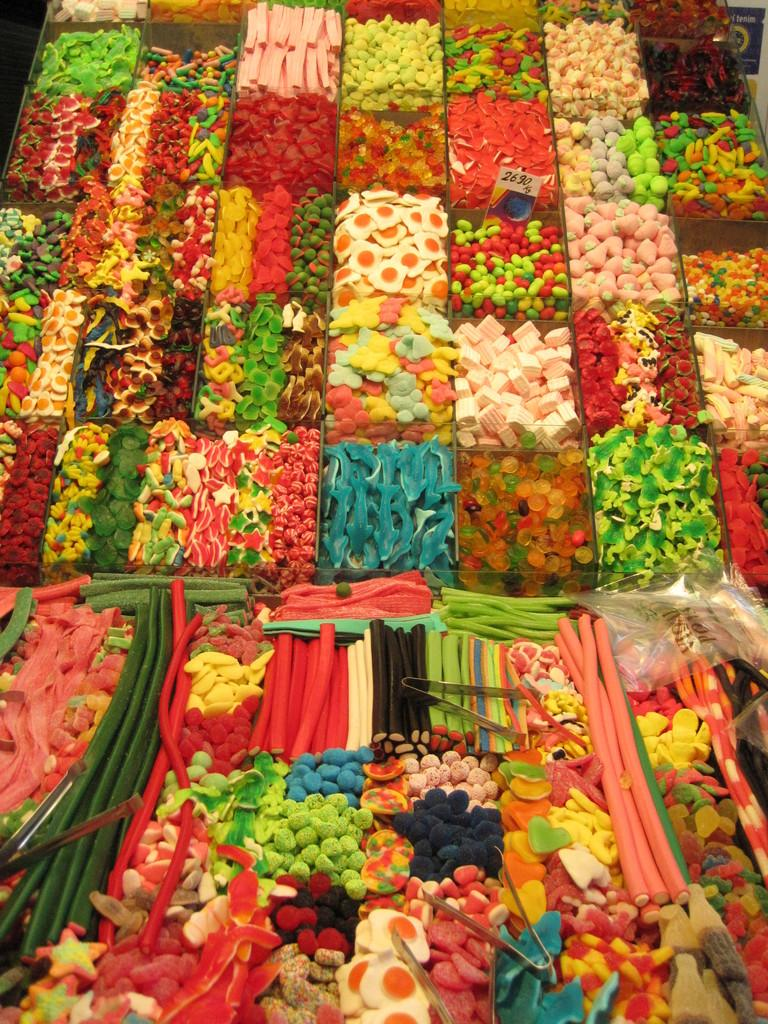What can be seen in the image related to food? There are different types of food items in the image. What tool is visible in the image that might be used to handle food? Tongs are visible in the image. Is there any information about the cost of the food items in the image? Yes, there is a price tag in the image. Can you describe any other objects in the image that are not related to food? There are some unspecified objects in the image. How does the system in the image help with swimming? There is no system or swimming activity depicted in the image; it features food items, tongs, a price tag, and unspecified objects. 